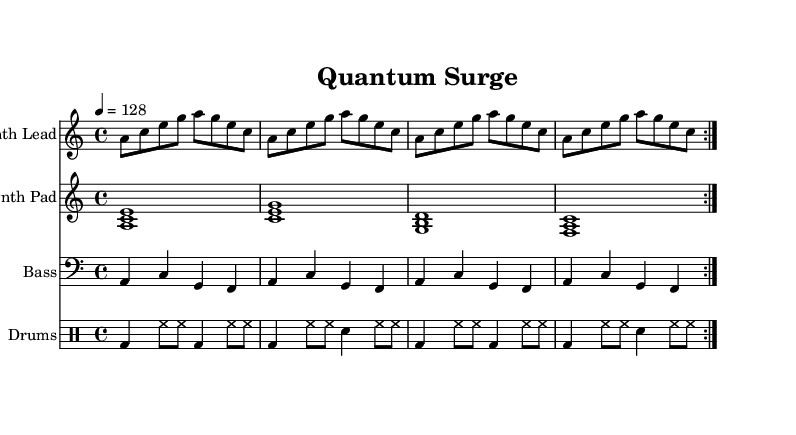What is the key signature of this music? The key signature shows 3 flats, which indicates the key of A minor.
Answer: A minor What is the time signature of the piece? The time signature appears at the beginning of the score and shows 4/4, meaning there are four beats in each measure.
Answer: 4/4 What is the tempo marking for this composition? The tempo marking indicates a speed of 128 beats per minute, which is a common tempo for house music.
Answer: 128 How many measures are there in the Synth Lead section? In the Synth Lead section, there are 8 measures shown, as indicated by the repetition markings in the score.
Answer: 8 What kind of instruments are featured in this composition? The score includes a Synth Lead, Synth Pad, Bass, and Drums, as indicated in the staff labels.
Answer: Synth Lead, Synth Pad, Bass, Drums Why is the bass line structured with repeated notes? Repeated notes in the bass line create a solid foundation for the rhythm and help to drive the groove characteristic of house music.
Answer: To drive the groove What is the rhythm pattern of the drums indicated in the score? The drum pattern is shown in the notation, characterized by a kick drum and hi-hat combination that creates a percussive driving beat often found in house music.
Answer: Kick drum and hi-hat combination 